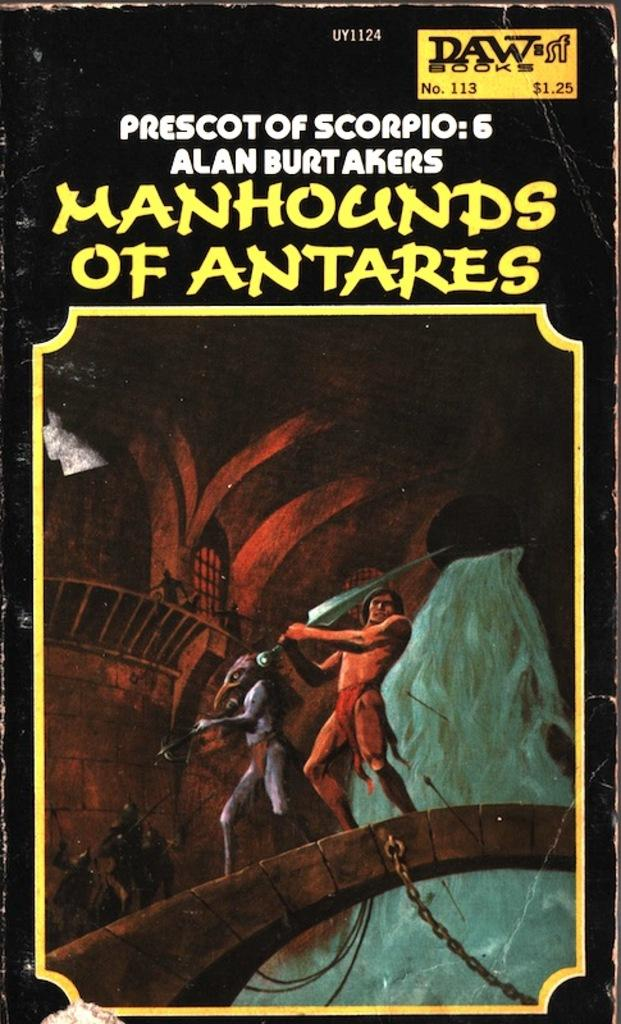<image>
Offer a succinct explanation of the picture presented. An old book with the title Prescot of Scorpio: 6 MANHOUNDS OF ANTARES. 